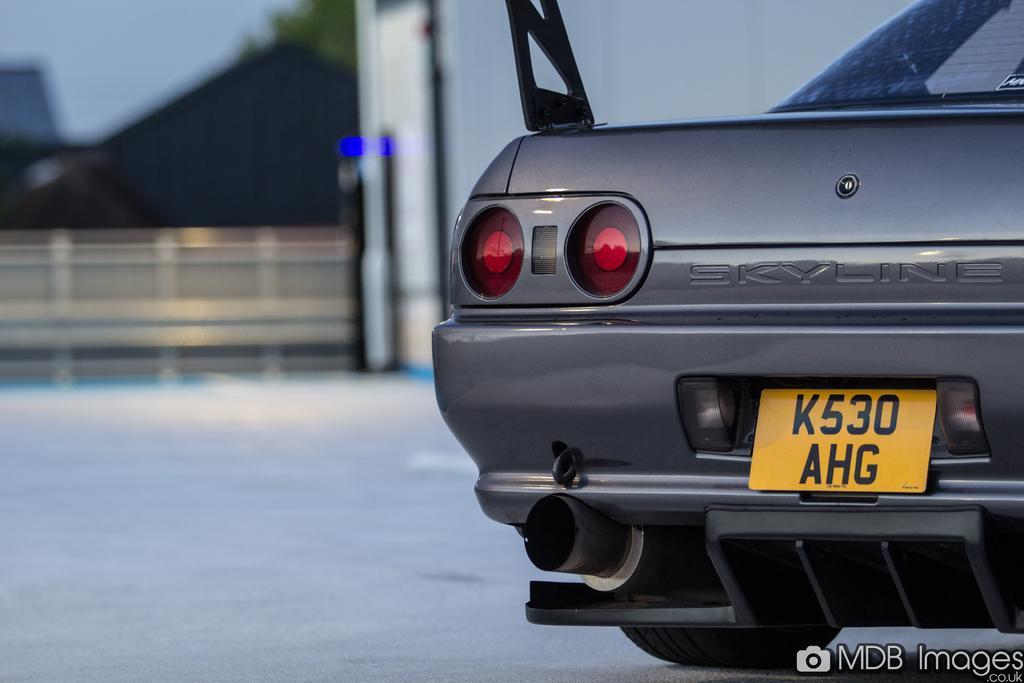Could you give a brief overview of what you see in this image? In this image I can see the ground and a car which is black, red and yellow in color on the ground. I can see the blurry background in which I can see few trees, the sky and few other objects. 